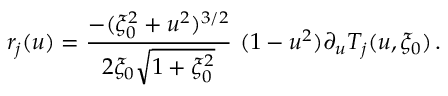Convert formula to latex. <formula><loc_0><loc_0><loc_500><loc_500>r _ { j } ( u ) = \frac { - ( \xi _ { 0 } ^ { 2 } + u ^ { 2 } ) ^ { 3 / 2 } } { 2 \xi _ { 0 } \sqrt { 1 + \xi _ { 0 } ^ { 2 } } } \, ( 1 - u ^ { 2 } ) \partial _ { u } T _ { j } ( u , \xi _ { 0 } ) \, .</formula> 